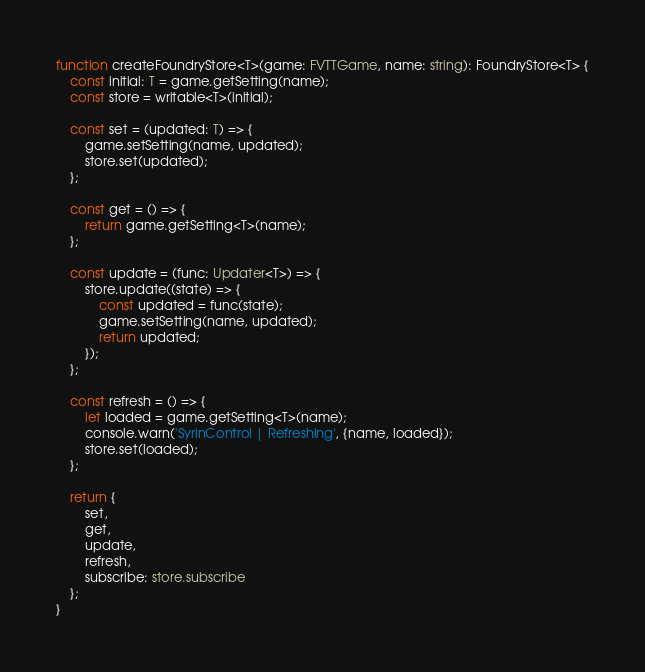<code> <loc_0><loc_0><loc_500><loc_500><_TypeScript_>function createFoundryStore<T>(game: FVTTGame, name: string): FoundryStore<T> {
	const initial: T = game.getSetting(name);
	const store = writable<T>(initial);

	const set = (updated: T) => {
		game.setSetting(name, updated);
		store.set(updated);
	};

	const get = () => {
		return game.getSetting<T>(name);
	};

	const update = (func: Updater<T>) => {
		store.update((state) => {
			const updated = func(state);
			game.setSetting(name, updated);
			return updated;
		});
	};

	const refresh = () => {
		let loaded = game.getSetting<T>(name);
		console.warn('SyrinControl | Refreshing', {name, loaded});
		store.set(loaded);
	};

	return {
		set,
		get,
		update,
		refresh,
		subscribe: store.subscribe
	};
}
</code> 